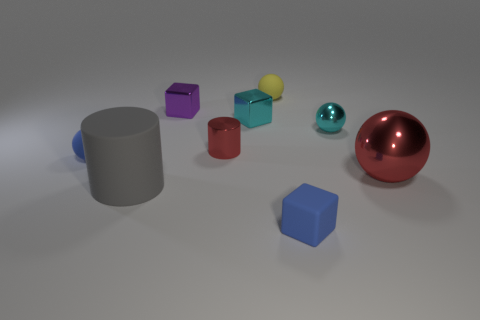Subtract all small yellow rubber balls. How many balls are left? 3 Add 1 tiny yellow matte cylinders. How many objects exist? 10 Subtract all gray cylinders. How many cylinders are left? 1 Subtract all balls. How many objects are left? 5 Subtract all big gray things. Subtract all small cyan metallic spheres. How many objects are left? 7 Add 8 big red shiny balls. How many big red shiny balls are left? 9 Add 1 cylinders. How many cylinders exist? 3 Subtract 0 yellow blocks. How many objects are left? 9 Subtract 1 balls. How many balls are left? 3 Subtract all green cylinders. Subtract all cyan spheres. How many cylinders are left? 2 